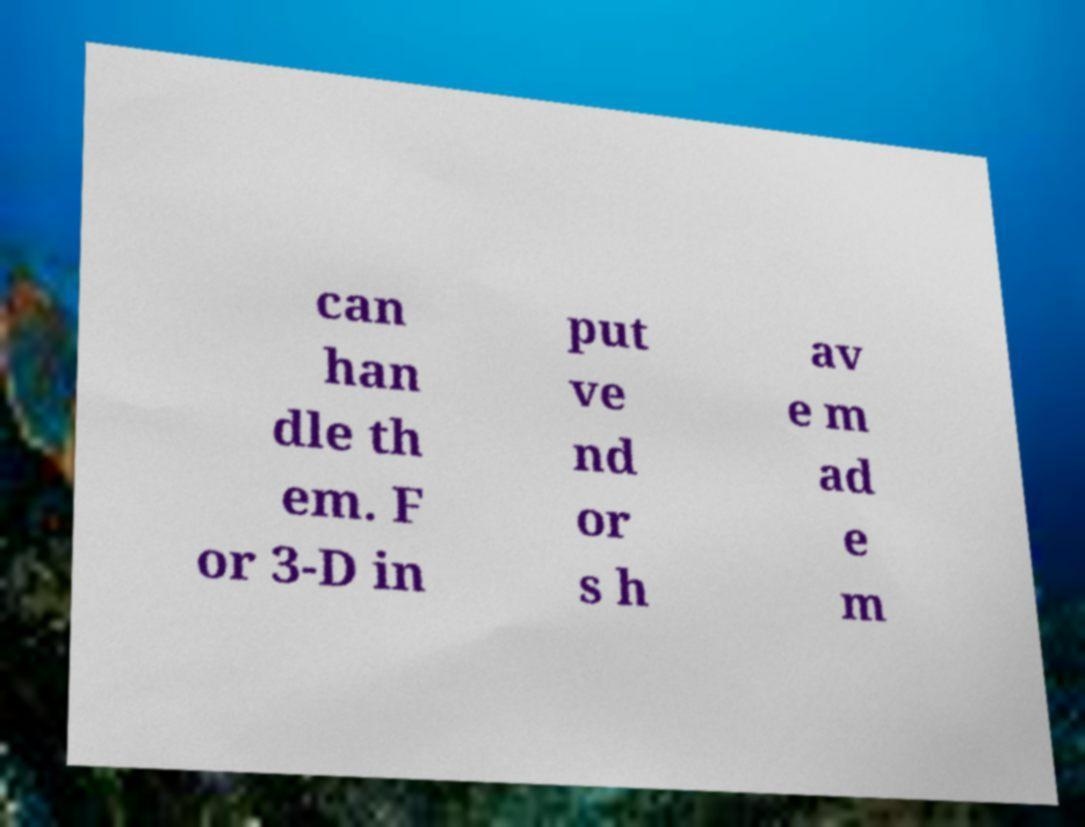Could you assist in decoding the text presented in this image and type it out clearly? can han dle th em. F or 3-D in put ve nd or s h av e m ad e m 